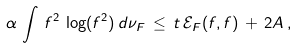<formula> <loc_0><loc_0><loc_500><loc_500>\alpha \, \int \, f ^ { 2 } \, \log ( f ^ { 2 } ) \, d \nu _ { F } \, \leq \, t \, \mathcal { E } _ { F } ( f , f ) \, + \, 2 A \, ,</formula> 